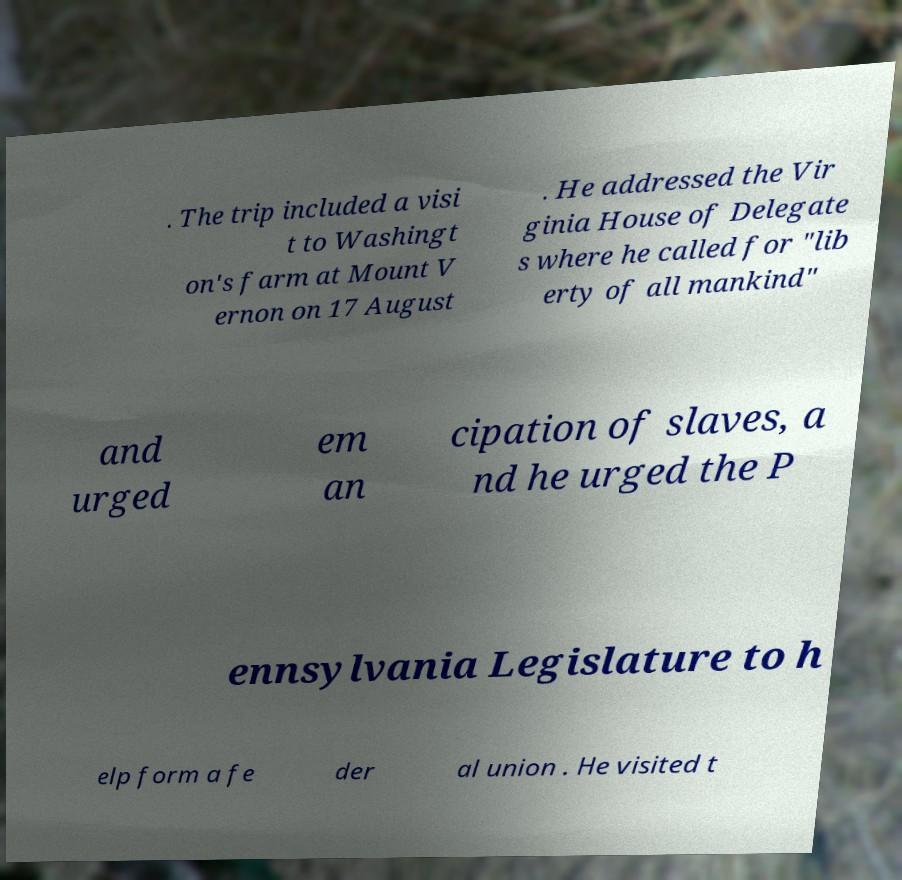Could you extract and type out the text from this image? . The trip included a visi t to Washingt on's farm at Mount V ernon on 17 August . He addressed the Vir ginia House of Delegate s where he called for "lib erty of all mankind" and urged em an cipation of slaves, a nd he urged the P ennsylvania Legislature to h elp form a fe der al union . He visited t 